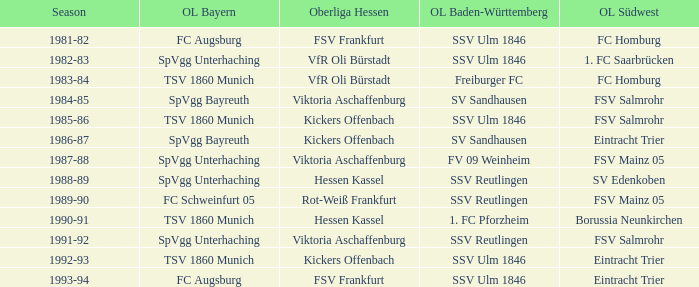Which oberliga südwes has an oberliga baden-württemberg of sv sandhausen in 1984-85? FSV Salmrohr. 